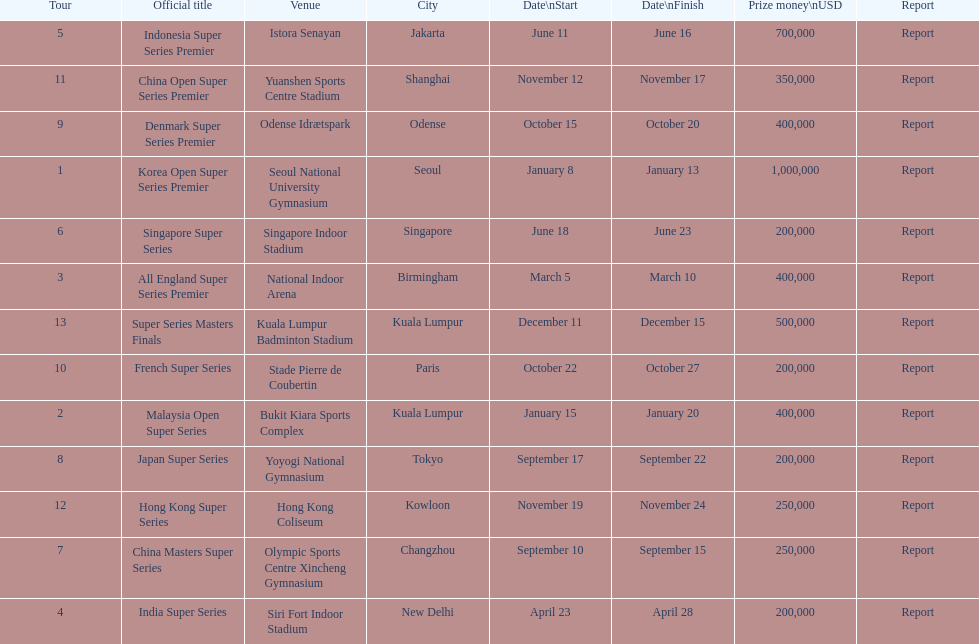Parse the full table. {'header': ['Tour', 'Official title', 'Venue', 'City', 'Date\\nStart', 'Date\\nFinish', 'Prize money\\nUSD', 'Report'], 'rows': [['5', 'Indonesia Super Series Premier', 'Istora Senayan', 'Jakarta', 'June 11', 'June 16', '700,000', 'Report'], ['11', 'China Open Super Series Premier', 'Yuanshen Sports Centre Stadium', 'Shanghai', 'November 12', 'November 17', '350,000', 'Report'], ['9', 'Denmark Super Series Premier', 'Odense Idrætspark', 'Odense', 'October 15', 'October 20', '400,000', 'Report'], ['1', 'Korea Open Super Series Premier', 'Seoul National University Gymnasium', 'Seoul', 'January 8', 'January 13', '1,000,000', 'Report'], ['6', 'Singapore Super Series', 'Singapore Indoor Stadium', 'Singapore', 'June 18', 'June 23', '200,000', 'Report'], ['3', 'All England Super Series Premier', 'National Indoor Arena', 'Birmingham', 'March 5', 'March 10', '400,000', 'Report'], ['13', 'Super Series Masters Finals', 'Kuala Lumpur Badminton Stadium', 'Kuala Lumpur', 'December 11', 'December 15', '500,000', 'Report'], ['10', 'French Super Series', 'Stade Pierre de Coubertin', 'Paris', 'October 22', 'October 27', '200,000', 'Report'], ['2', 'Malaysia Open Super Series', 'Bukit Kiara Sports Complex', 'Kuala Lumpur', 'January 15', 'January 20', '400,000', 'Report'], ['8', 'Japan Super Series', 'Yoyogi National Gymnasium', 'Tokyo', 'September 17', 'September 22', '200,000', 'Report'], ['12', 'Hong Kong Super Series', 'Hong Kong Coliseum', 'Kowloon', 'November 19', 'November 24', '250,000', 'Report'], ['7', 'China Masters Super Series', 'Olympic Sports Centre Xincheng Gymnasium', 'Changzhou', 'September 10', 'September 15', '250,000', 'Report'], ['4', 'India Super Series', 'Siri Fort Indoor Stadium', 'New Delhi', 'April 23', 'April 28', '200,000', 'Report']]} How long did the japan super series take? 5 days. 